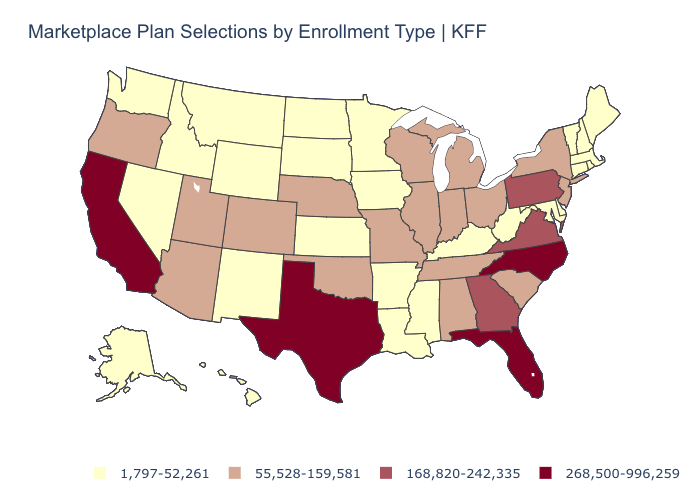Which states have the lowest value in the Northeast?
Short answer required. Connecticut, Maine, Massachusetts, New Hampshire, Rhode Island, Vermont. Is the legend a continuous bar?
Answer briefly. No. Which states have the lowest value in the USA?
Be succinct. Alaska, Arkansas, Connecticut, Delaware, Hawaii, Idaho, Iowa, Kansas, Kentucky, Louisiana, Maine, Maryland, Massachusetts, Minnesota, Mississippi, Montana, Nevada, New Hampshire, New Mexico, North Dakota, Rhode Island, South Dakota, Vermont, Washington, West Virginia, Wyoming. Which states hav the highest value in the Northeast?
Be succinct. Pennsylvania. Among the states that border Wyoming , which have the highest value?
Quick response, please. Colorado, Nebraska, Utah. Name the states that have a value in the range 1,797-52,261?
Answer briefly. Alaska, Arkansas, Connecticut, Delaware, Hawaii, Idaho, Iowa, Kansas, Kentucky, Louisiana, Maine, Maryland, Massachusetts, Minnesota, Mississippi, Montana, Nevada, New Hampshire, New Mexico, North Dakota, Rhode Island, South Dakota, Vermont, Washington, West Virginia, Wyoming. Name the states that have a value in the range 268,500-996,259?
Quick response, please. California, Florida, North Carolina, Texas. Which states have the lowest value in the Northeast?
Short answer required. Connecticut, Maine, Massachusetts, New Hampshire, Rhode Island, Vermont. What is the lowest value in the Northeast?
Write a very short answer. 1,797-52,261. Name the states that have a value in the range 268,500-996,259?
Keep it brief. California, Florida, North Carolina, Texas. Is the legend a continuous bar?
Give a very brief answer. No. Does the first symbol in the legend represent the smallest category?
Concise answer only. Yes. How many symbols are there in the legend?
Quick response, please. 4. Name the states that have a value in the range 168,820-242,335?
Be succinct. Georgia, Pennsylvania, Virginia. Among the states that border Utah , does Nevada have the lowest value?
Keep it brief. Yes. 